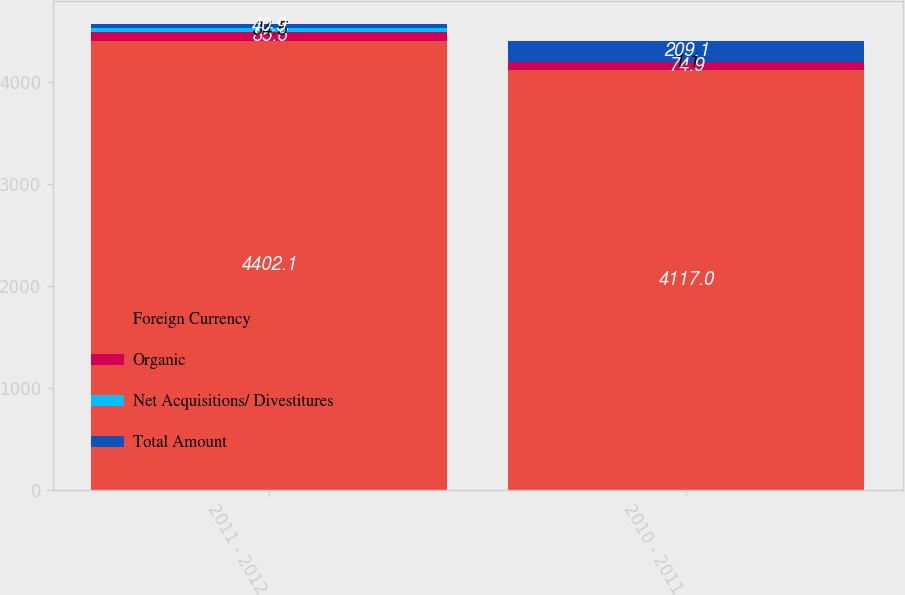Convert chart to OTSL. <chart><loc_0><loc_0><loc_500><loc_500><stacked_bar_chart><ecel><fcel>2011 - 2012<fcel>2010 - 2011<nl><fcel>Foreign Currency<fcel>4402.1<fcel>4117<nl><fcel>Organic<fcel>85.6<fcel>74.9<nl><fcel>Net Acquisitions/ Divestitures<fcel>34.5<fcel>1.1<nl><fcel>Total Amount<fcel>40.9<fcel>209.1<nl></chart> 